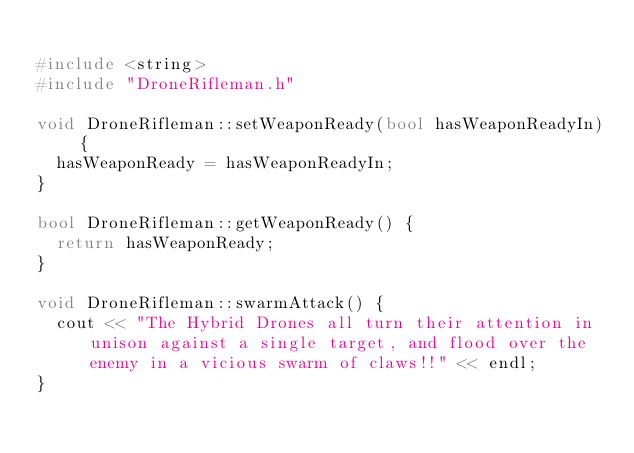<code> <loc_0><loc_0><loc_500><loc_500><_C++_>
#include <string>
#include "DroneRifleman.h"

void DroneRifleman::setWeaponReady(bool hasWeaponReadyIn) {
	hasWeaponReady = hasWeaponReadyIn;
}

bool DroneRifleman::getWeaponReady() {
	return hasWeaponReady;
}

void DroneRifleman::swarmAttack() {
	cout << "The Hybrid Drones all turn their attention in unison against a single target, and flood over the enemy in a vicious swarm of claws!!" << endl;
}</code> 